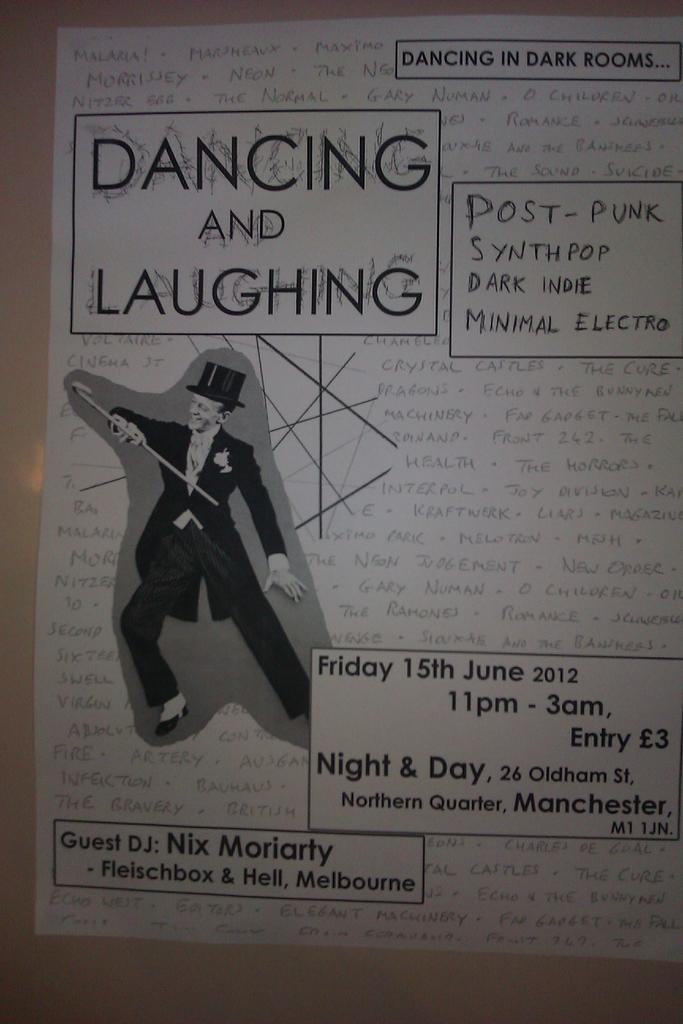<image>
Summarize the visual content of the image. The poster says dancing and laughing on it 